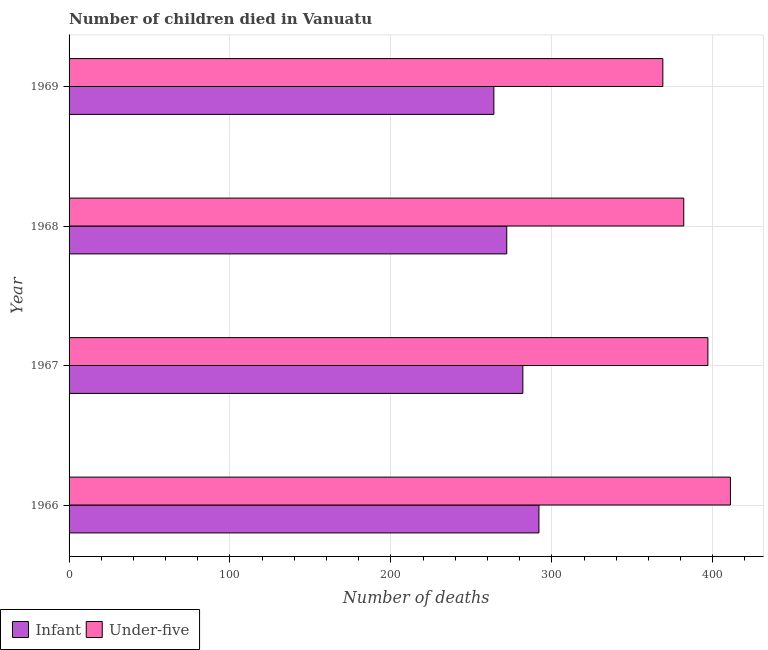Are the number of bars on each tick of the Y-axis equal?
Your answer should be very brief. Yes. What is the label of the 4th group of bars from the top?
Offer a terse response. 1966. In how many cases, is the number of bars for a given year not equal to the number of legend labels?
Ensure brevity in your answer.  0. What is the number of infant deaths in 1966?
Make the answer very short. 292. Across all years, what is the maximum number of infant deaths?
Your response must be concise. 292. Across all years, what is the minimum number of infant deaths?
Keep it short and to the point. 264. In which year was the number of under-five deaths maximum?
Give a very brief answer. 1966. In which year was the number of under-five deaths minimum?
Provide a succinct answer. 1969. What is the total number of under-five deaths in the graph?
Provide a succinct answer. 1559. What is the difference between the number of infant deaths in 1968 and that in 1969?
Offer a very short reply. 8. What is the difference between the number of under-five deaths in 1967 and the number of infant deaths in 1968?
Offer a very short reply. 125. What is the average number of under-five deaths per year?
Offer a terse response. 389.75. In the year 1966, what is the difference between the number of under-five deaths and number of infant deaths?
Your response must be concise. 119. In how many years, is the number of infant deaths greater than 240 ?
Provide a succinct answer. 4. What is the ratio of the number of under-five deaths in 1966 to that in 1969?
Provide a short and direct response. 1.11. What is the difference between the highest and the second highest number of under-five deaths?
Provide a succinct answer. 14. What is the difference between the highest and the lowest number of under-five deaths?
Offer a terse response. 42. In how many years, is the number of under-five deaths greater than the average number of under-five deaths taken over all years?
Make the answer very short. 2. Is the sum of the number of infant deaths in 1966 and 1968 greater than the maximum number of under-five deaths across all years?
Ensure brevity in your answer.  Yes. What does the 1st bar from the top in 1968 represents?
Ensure brevity in your answer.  Under-five. What does the 2nd bar from the bottom in 1966 represents?
Make the answer very short. Under-five. How many years are there in the graph?
Your answer should be very brief. 4. What is the difference between two consecutive major ticks on the X-axis?
Ensure brevity in your answer.  100. How are the legend labels stacked?
Make the answer very short. Horizontal. What is the title of the graph?
Offer a very short reply. Number of children died in Vanuatu. Does "Quality of trade" appear as one of the legend labels in the graph?
Offer a terse response. No. What is the label or title of the X-axis?
Provide a succinct answer. Number of deaths. What is the Number of deaths in Infant in 1966?
Give a very brief answer. 292. What is the Number of deaths of Under-five in 1966?
Give a very brief answer. 411. What is the Number of deaths in Infant in 1967?
Offer a terse response. 282. What is the Number of deaths in Under-five in 1967?
Keep it short and to the point. 397. What is the Number of deaths in Infant in 1968?
Keep it short and to the point. 272. What is the Number of deaths of Under-five in 1968?
Provide a short and direct response. 382. What is the Number of deaths of Infant in 1969?
Offer a terse response. 264. What is the Number of deaths of Under-five in 1969?
Provide a short and direct response. 369. Across all years, what is the maximum Number of deaths of Infant?
Provide a succinct answer. 292. Across all years, what is the maximum Number of deaths in Under-five?
Ensure brevity in your answer.  411. Across all years, what is the minimum Number of deaths of Infant?
Provide a succinct answer. 264. Across all years, what is the minimum Number of deaths in Under-five?
Your answer should be very brief. 369. What is the total Number of deaths in Infant in the graph?
Ensure brevity in your answer.  1110. What is the total Number of deaths in Under-five in the graph?
Your answer should be very brief. 1559. What is the difference between the Number of deaths in Infant in 1966 and that in 1967?
Ensure brevity in your answer.  10. What is the difference between the Number of deaths of Under-five in 1966 and that in 1967?
Your answer should be compact. 14. What is the difference between the Number of deaths in Infant in 1966 and that in 1968?
Make the answer very short. 20. What is the difference between the Number of deaths of Under-five in 1966 and that in 1968?
Your answer should be compact. 29. What is the difference between the Number of deaths of Under-five in 1966 and that in 1969?
Make the answer very short. 42. What is the difference between the Number of deaths of Infant in 1967 and that in 1968?
Provide a short and direct response. 10. What is the difference between the Number of deaths in Under-five in 1967 and that in 1968?
Your answer should be compact. 15. What is the difference between the Number of deaths in Under-five in 1967 and that in 1969?
Ensure brevity in your answer.  28. What is the difference between the Number of deaths of Under-five in 1968 and that in 1969?
Offer a very short reply. 13. What is the difference between the Number of deaths of Infant in 1966 and the Number of deaths of Under-five in 1967?
Provide a succinct answer. -105. What is the difference between the Number of deaths of Infant in 1966 and the Number of deaths of Under-five in 1968?
Keep it short and to the point. -90. What is the difference between the Number of deaths in Infant in 1966 and the Number of deaths in Under-five in 1969?
Give a very brief answer. -77. What is the difference between the Number of deaths of Infant in 1967 and the Number of deaths of Under-five in 1968?
Your answer should be very brief. -100. What is the difference between the Number of deaths of Infant in 1967 and the Number of deaths of Under-five in 1969?
Your answer should be compact. -87. What is the difference between the Number of deaths of Infant in 1968 and the Number of deaths of Under-five in 1969?
Offer a terse response. -97. What is the average Number of deaths of Infant per year?
Your answer should be very brief. 277.5. What is the average Number of deaths in Under-five per year?
Your answer should be very brief. 389.75. In the year 1966, what is the difference between the Number of deaths of Infant and Number of deaths of Under-five?
Your answer should be very brief. -119. In the year 1967, what is the difference between the Number of deaths of Infant and Number of deaths of Under-five?
Offer a terse response. -115. In the year 1968, what is the difference between the Number of deaths of Infant and Number of deaths of Under-five?
Keep it short and to the point. -110. In the year 1969, what is the difference between the Number of deaths of Infant and Number of deaths of Under-five?
Your answer should be compact. -105. What is the ratio of the Number of deaths in Infant in 1966 to that in 1967?
Make the answer very short. 1.04. What is the ratio of the Number of deaths in Under-five in 1966 to that in 1967?
Provide a succinct answer. 1.04. What is the ratio of the Number of deaths of Infant in 1966 to that in 1968?
Give a very brief answer. 1.07. What is the ratio of the Number of deaths in Under-five in 1966 to that in 1968?
Ensure brevity in your answer.  1.08. What is the ratio of the Number of deaths of Infant in 1966 to that in 1969?
Give a very brief answer. 1.11. What is the ratio of the Number of deaths of Under-five in 1966 to that in 1969?
Provide a short and direct response. 1.11. What is the ratio of the Number of deaths in Infant in 1967 to that in 1968?
Offer a very short reply. 1.04. What is the ratio of the Number of deaths in Under-five in 1967 to that in 1968?
Ensure brevity in your answer.  1.04. What is the ratio of the Number of deaths in Infant in 1967 to that in 1969?
Offer a terse response. 1.07. What is the ratio of the Number of deaths in Under-five in 1967 to that in 1969?
Ensure brevity in your answer.  1.08. What is the ratio of the Number of deaths of Infant in 1968 to that in 1969?
Ensure brevity in your answer.  1.03. What is the ratio of the Number of deaths in Under-five in 1968 to that in 1969?
Your response must be concise. 1.04. 